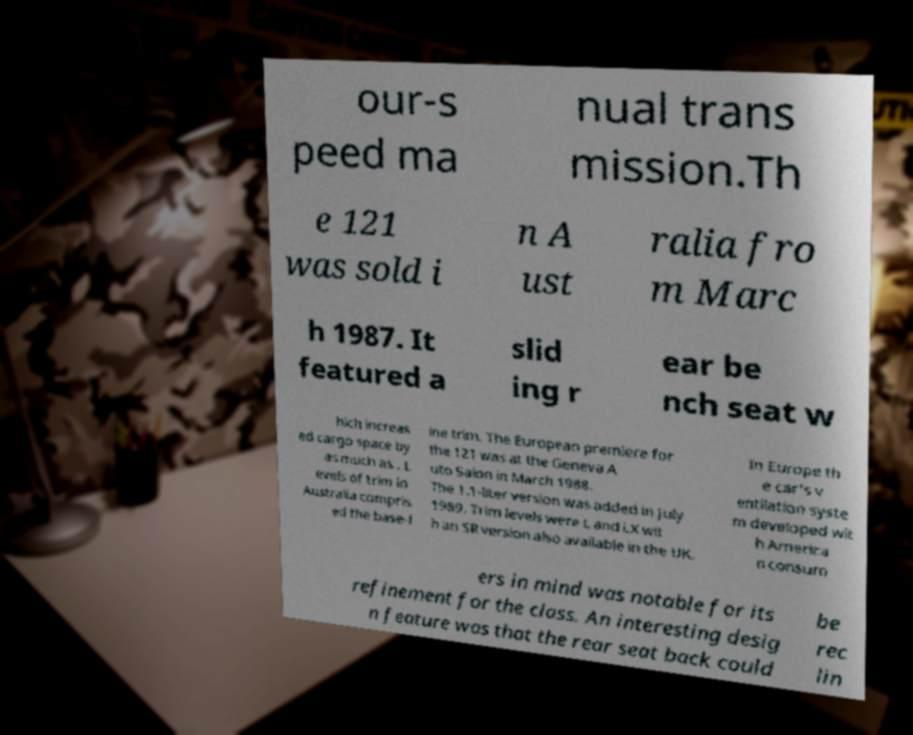Please read and relay the text visible in this image. What does it say? our-s peed ma nual trans mission.Th e 121 was sold i n A ust ralia fro m Marc h 1987. It featured a slid ing r ear be nch seat w hich increas ed cargo space by as much as . L evels of trim in Australia compris ed the base-l ine trim. The European premiere for the 121 was at the Geneva A uto Salon in March 1988. The 1.1-liter version was added in July 1989. Trim levels were L and LX wit h an SR version also available in the UK. In Europe th e car's v entilation syste m developed wit h America n consum ers in mind was notable for its refinement for the class. An interesting desig n feature was that the rear seat back could be rec lin 